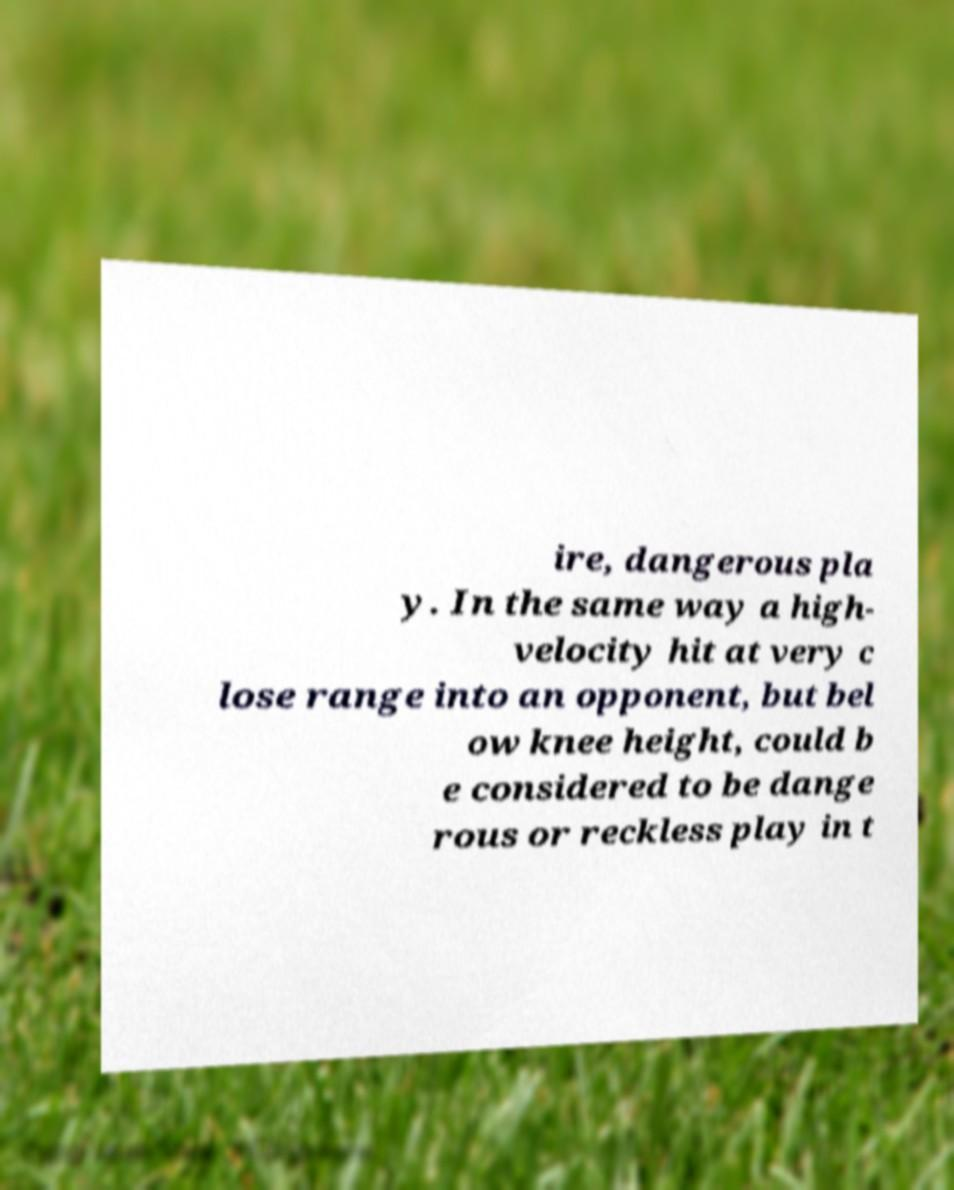For documentation purposes, I need the text within this image transcribed. Could you provide that? ire, dangerous pla y. In the same way a high- velocity hit at very c lose range into an opponent, but bel ow knee height, could b e considered to be dange rous or reckless play in t 